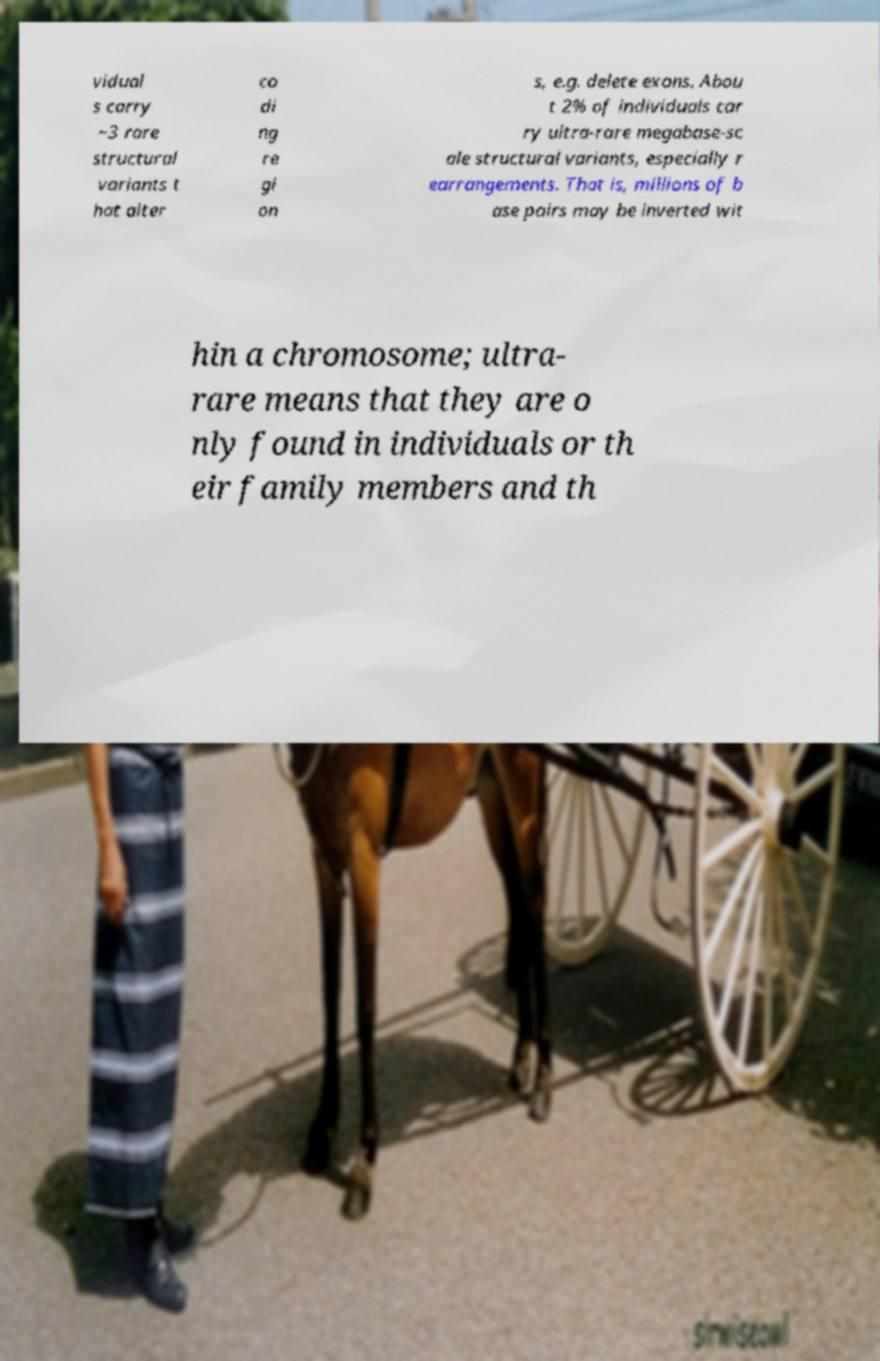Can you accurately transcribe the text from the provided image for me? vidual s carry ~3 rare structural variants t hat alter co di ng re gi on s, e.g. delete exons. Abou t 2% of individuals car ry ultra-rare megabase-sc ale structural variants, especially r earrangements. That is, millions of b ase pairs may be inverted wit hin a chromosome; ultra- rare means that they are o nly found in individuals or th eir family members and th 